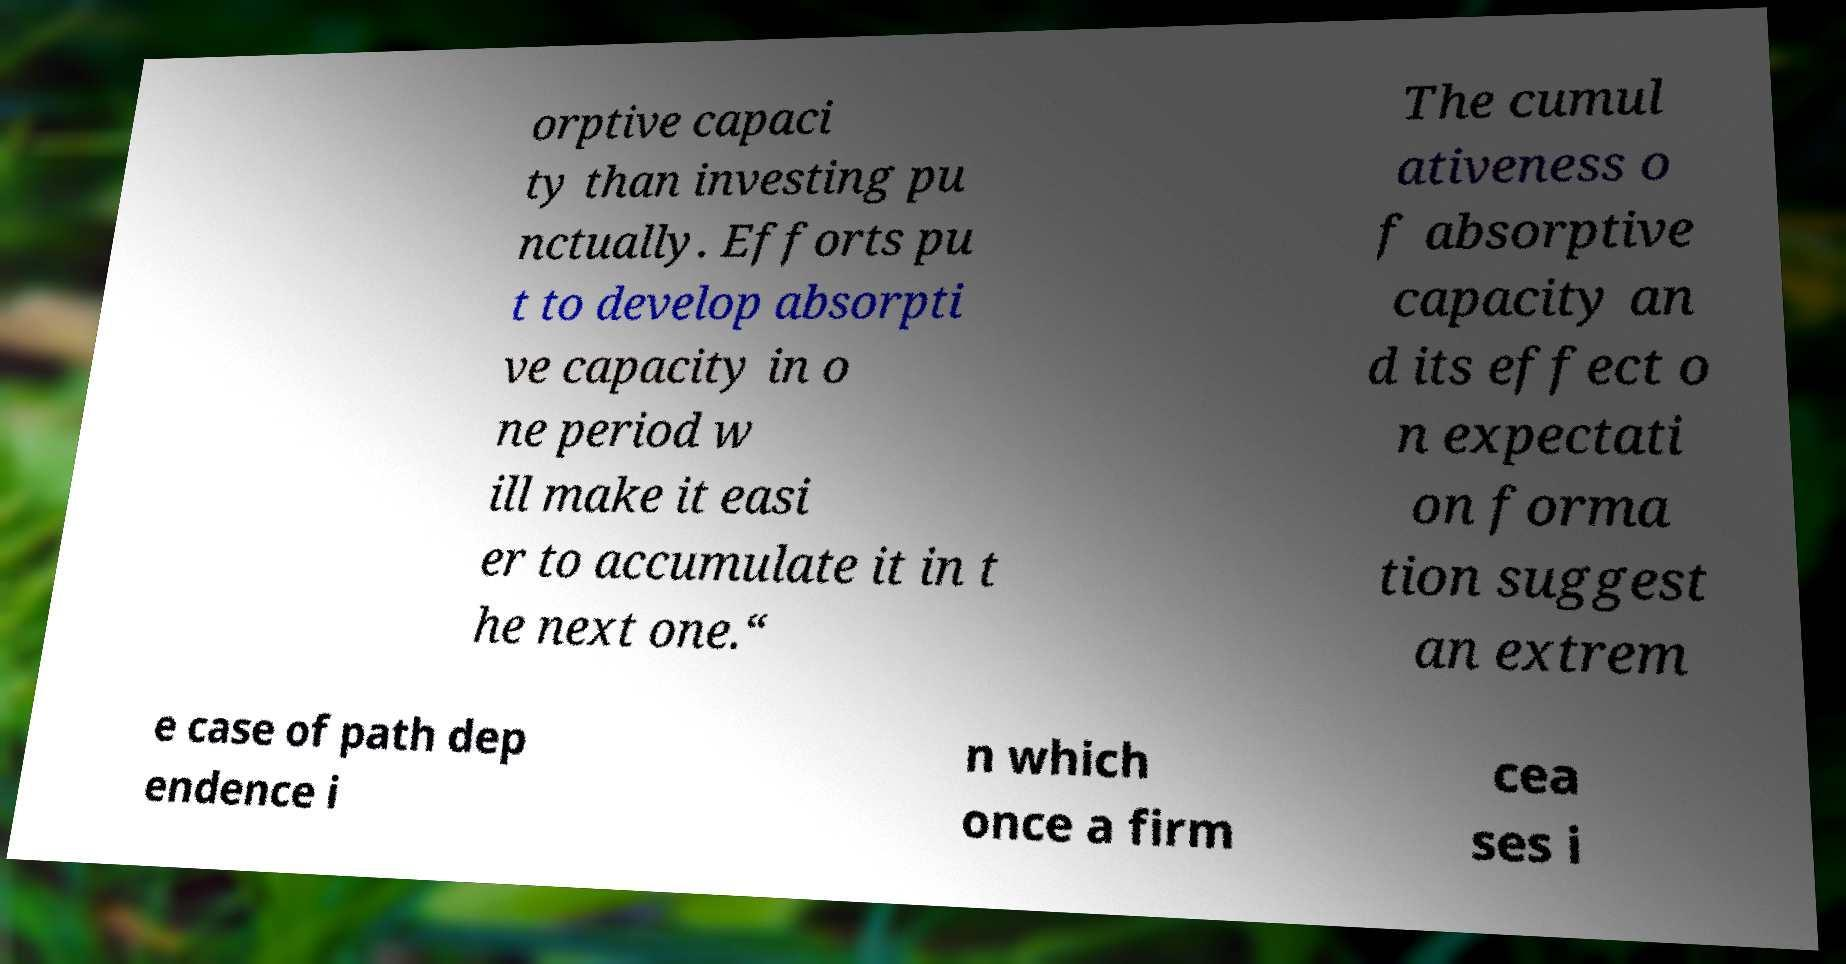There's text embedded in this image that I need extracted. Can you transcribe it verbatim? orptive capaci ty than investing pu nctually. Efforts pu t to develop absorpti ve capacity in o ne period w ill make it easi er to accumulate it in t he next one.“ The cumul ativeness o f absorptive capacity an d its effect o n expectati on forma tion suggest an extrem e case of path dep endence i n which once a firm cea ses i 